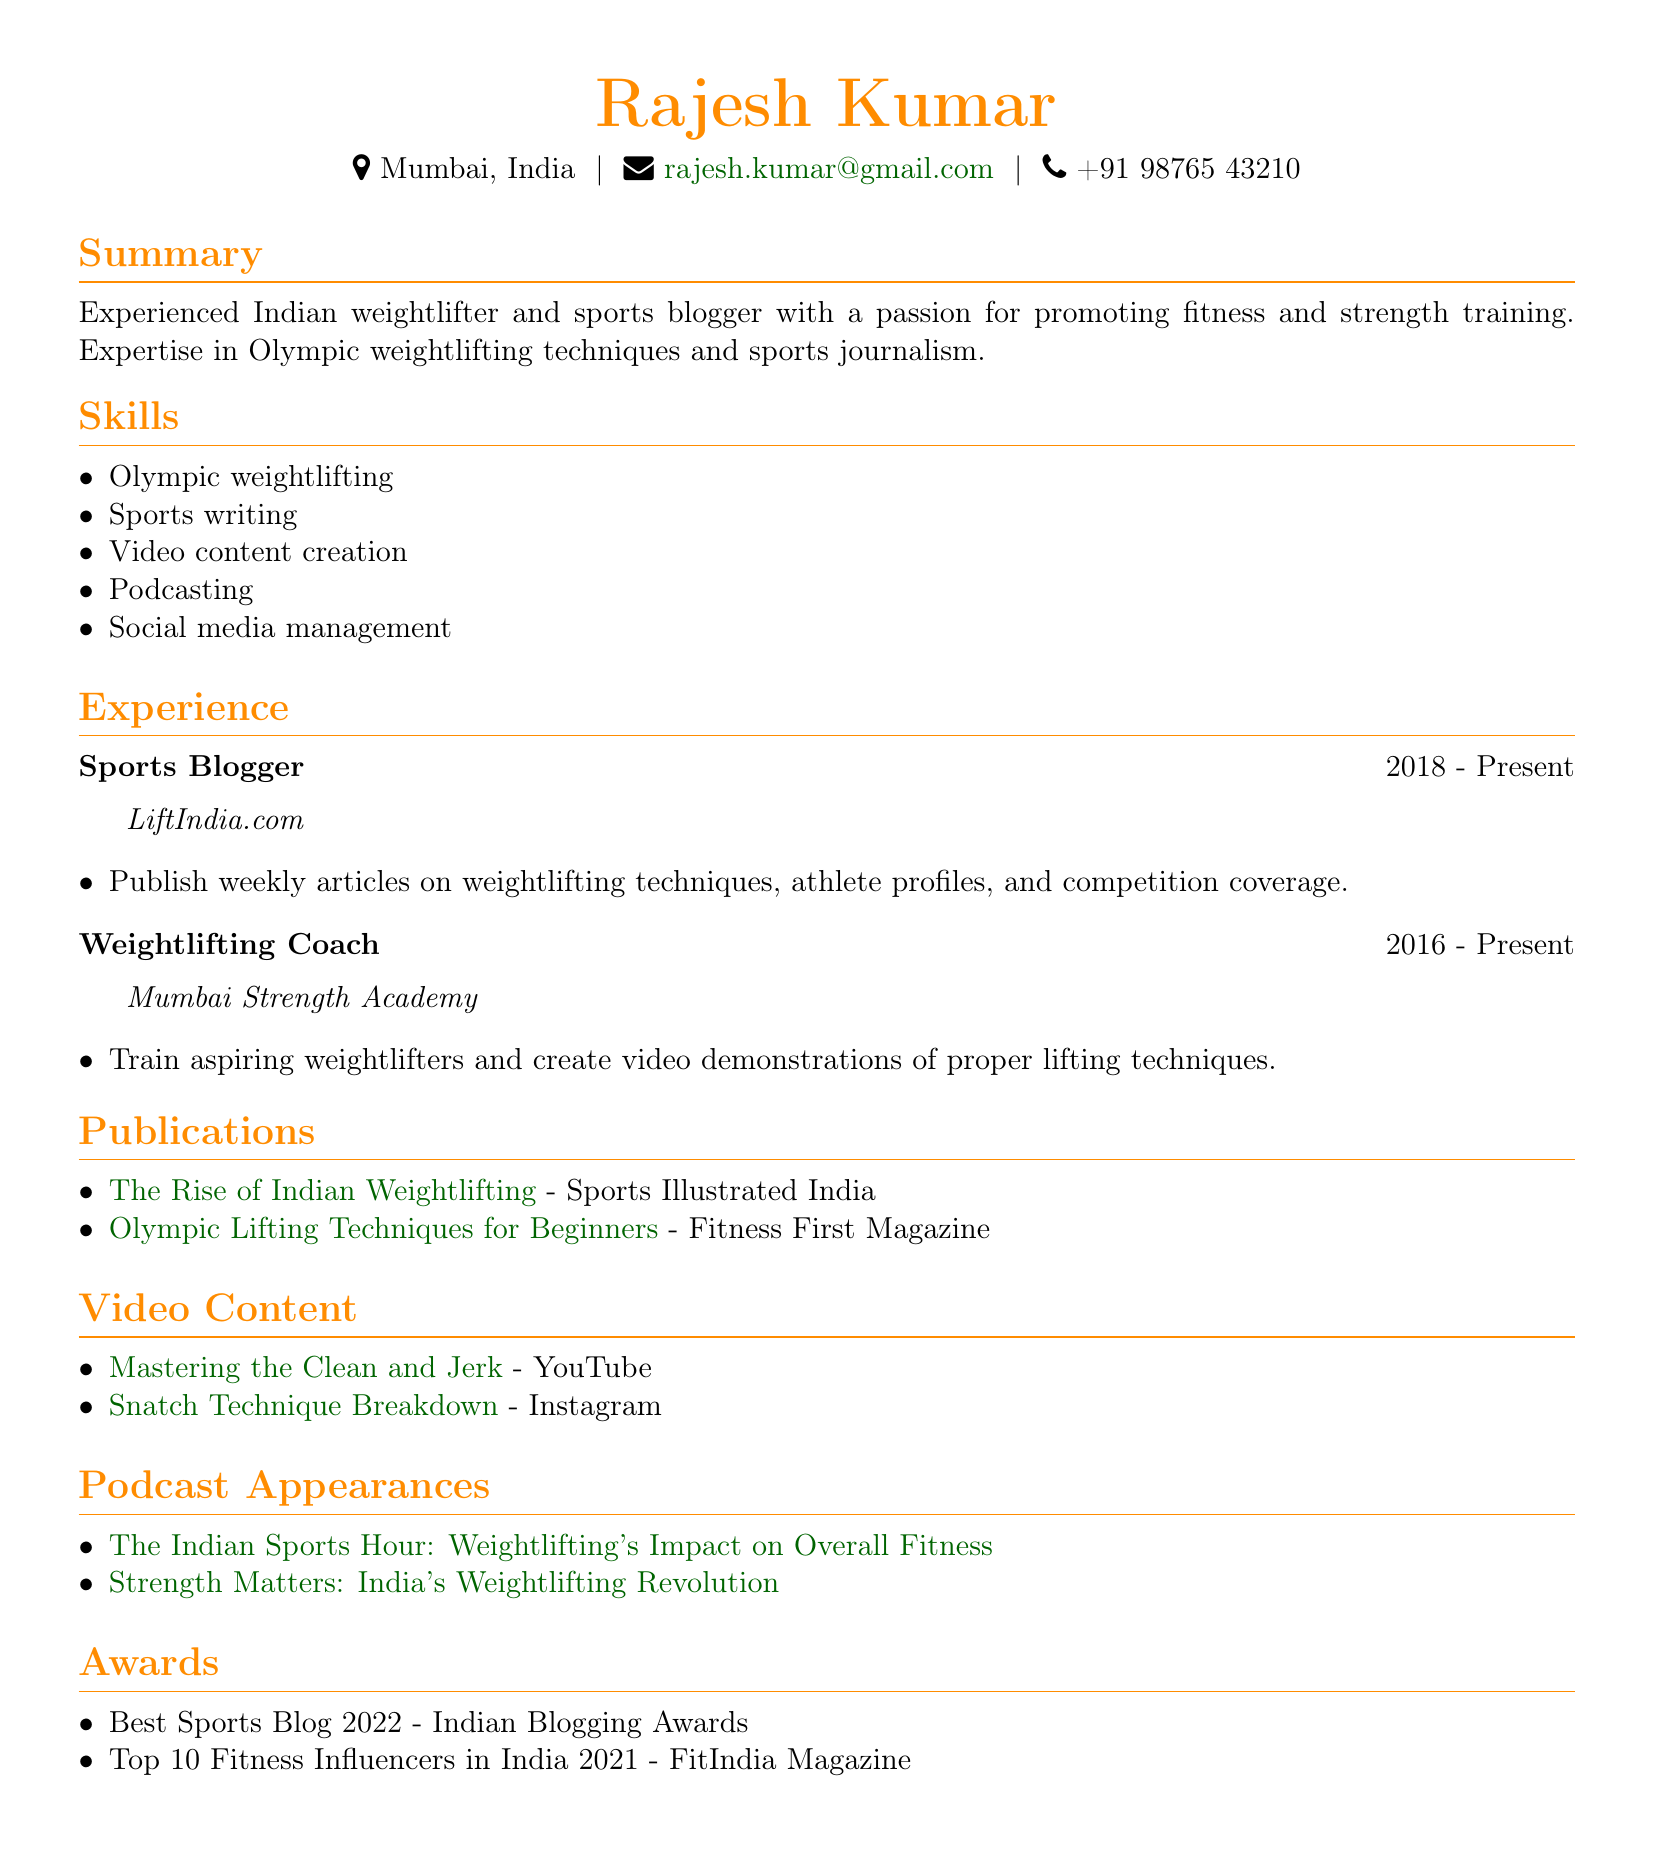What is the name of the individual? The name of the individual is presented in the personal info section of the document.
Answer: Rajesh Kumar Where does Rajesh Kumar live? The location of Rajesh Kumar is mentioned in the personal info section.
Answer: Mumbai, India What is Rajesh Kumar's email address? The email address is listed in the personal info section of the document.
Answer: rajesh.kumar@gmail.com What is one of Rajesh Kumar's skills? The skills section includes several areas of expertise, indicating the individual's capabilities.
Answer: Olympic weightlifting What is the name of the publication where Rajesh Kumar's article "The Rise of Indian Weightlifting" appeared? This information can be found in the publications section of the document.
Answer: Sports Illustrated India In what year did Rajesh Kumar start blogging for LiftIndia.com? The experience section provides the starting year for the blogging position.
Answer: 2018 How many awards has Rajesh Kumar received? The awards section lists two specific awards received by Rajesh Kumar.
Answer: 2 On which platform is the video "Mastering the Clean and Jerk" available? The video content section specifies the platform associated with the video.
Answer: YouTube What podcast features Rajesh Kumar discussing 'India's Weightlifting Revolution'? The podcast appearances section mentions the show name related to this discussion.
Answer: Strength Matters 